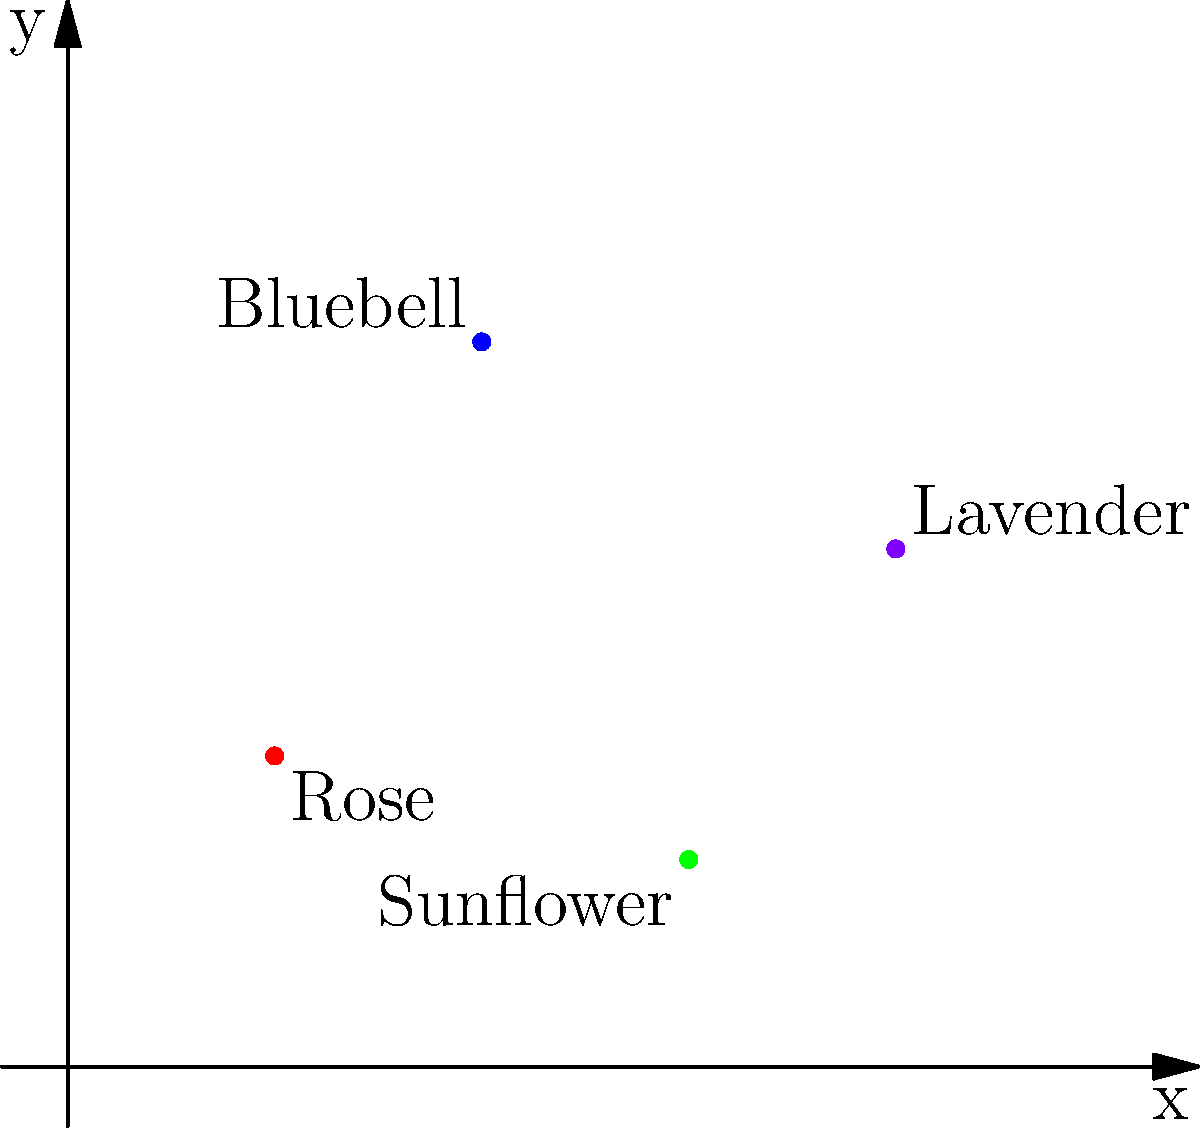In a botanical garden, four different flower species have been planted at specific locations. The garden is represented by a 2D coordinate system where each unit represents 1 meter. Given the coordinates of each flower species:

Rose: (2, 3)
Bluebell: (4, 7)
Sunflower: (6, 2)
Lavender: (8, 5)

What is the Manhattan distance between the Rose and the Lavender? To solve this problem, we need to follow these steps:

1. Understand the concept of Manhattan distance:
   The Manhattan distance is the sum of the absolute differences of the coordinates. It's called the Manhattan distance because it's the distance a car would drive in a city laid out in square blocks, like Manhattan.

2. Identify the coordinates:
   Rose: (2, 3)
   Lavender: (8, 5)

3. Calculate the Manhattan distance using the formula:
   Manhattan distance = |x₁ - x₂| + |y₁ - y₂|
   Where (x₁, y₁) are the coordinates of the first point, and (x₂, y₂) are the coordinates of the second point.

4. Plug in the values:
   |x₁ - x₂| = |2 - 8| = |-6| = 6
   |y₁ - y₂| = |3 - 5| = |-2| = 2

5. Sum the absolute differences:
   Manhattan distance = 6 + 2 = 8

Therefore, the Manhattan distance between the Rose and the Lavender is 8 meters.
Answer: 8 meters 